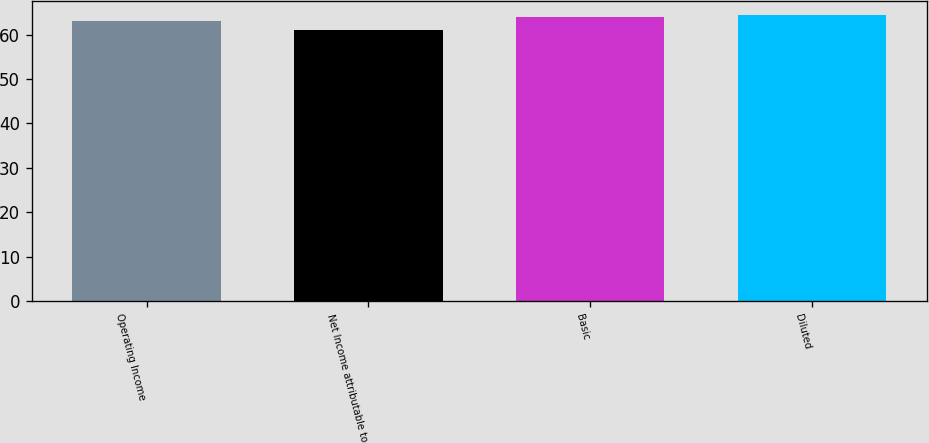Convert chart. <chart><loc_0><loc_0><loc_500><loc_500><bar_chart><fcel>Operating Income<fcel>Net Income attributable to<fcel>Basic<fcel>Diluted<nl><fcel>63<fcel>61<fcel>64<fcel>64.3<nl></chart> 